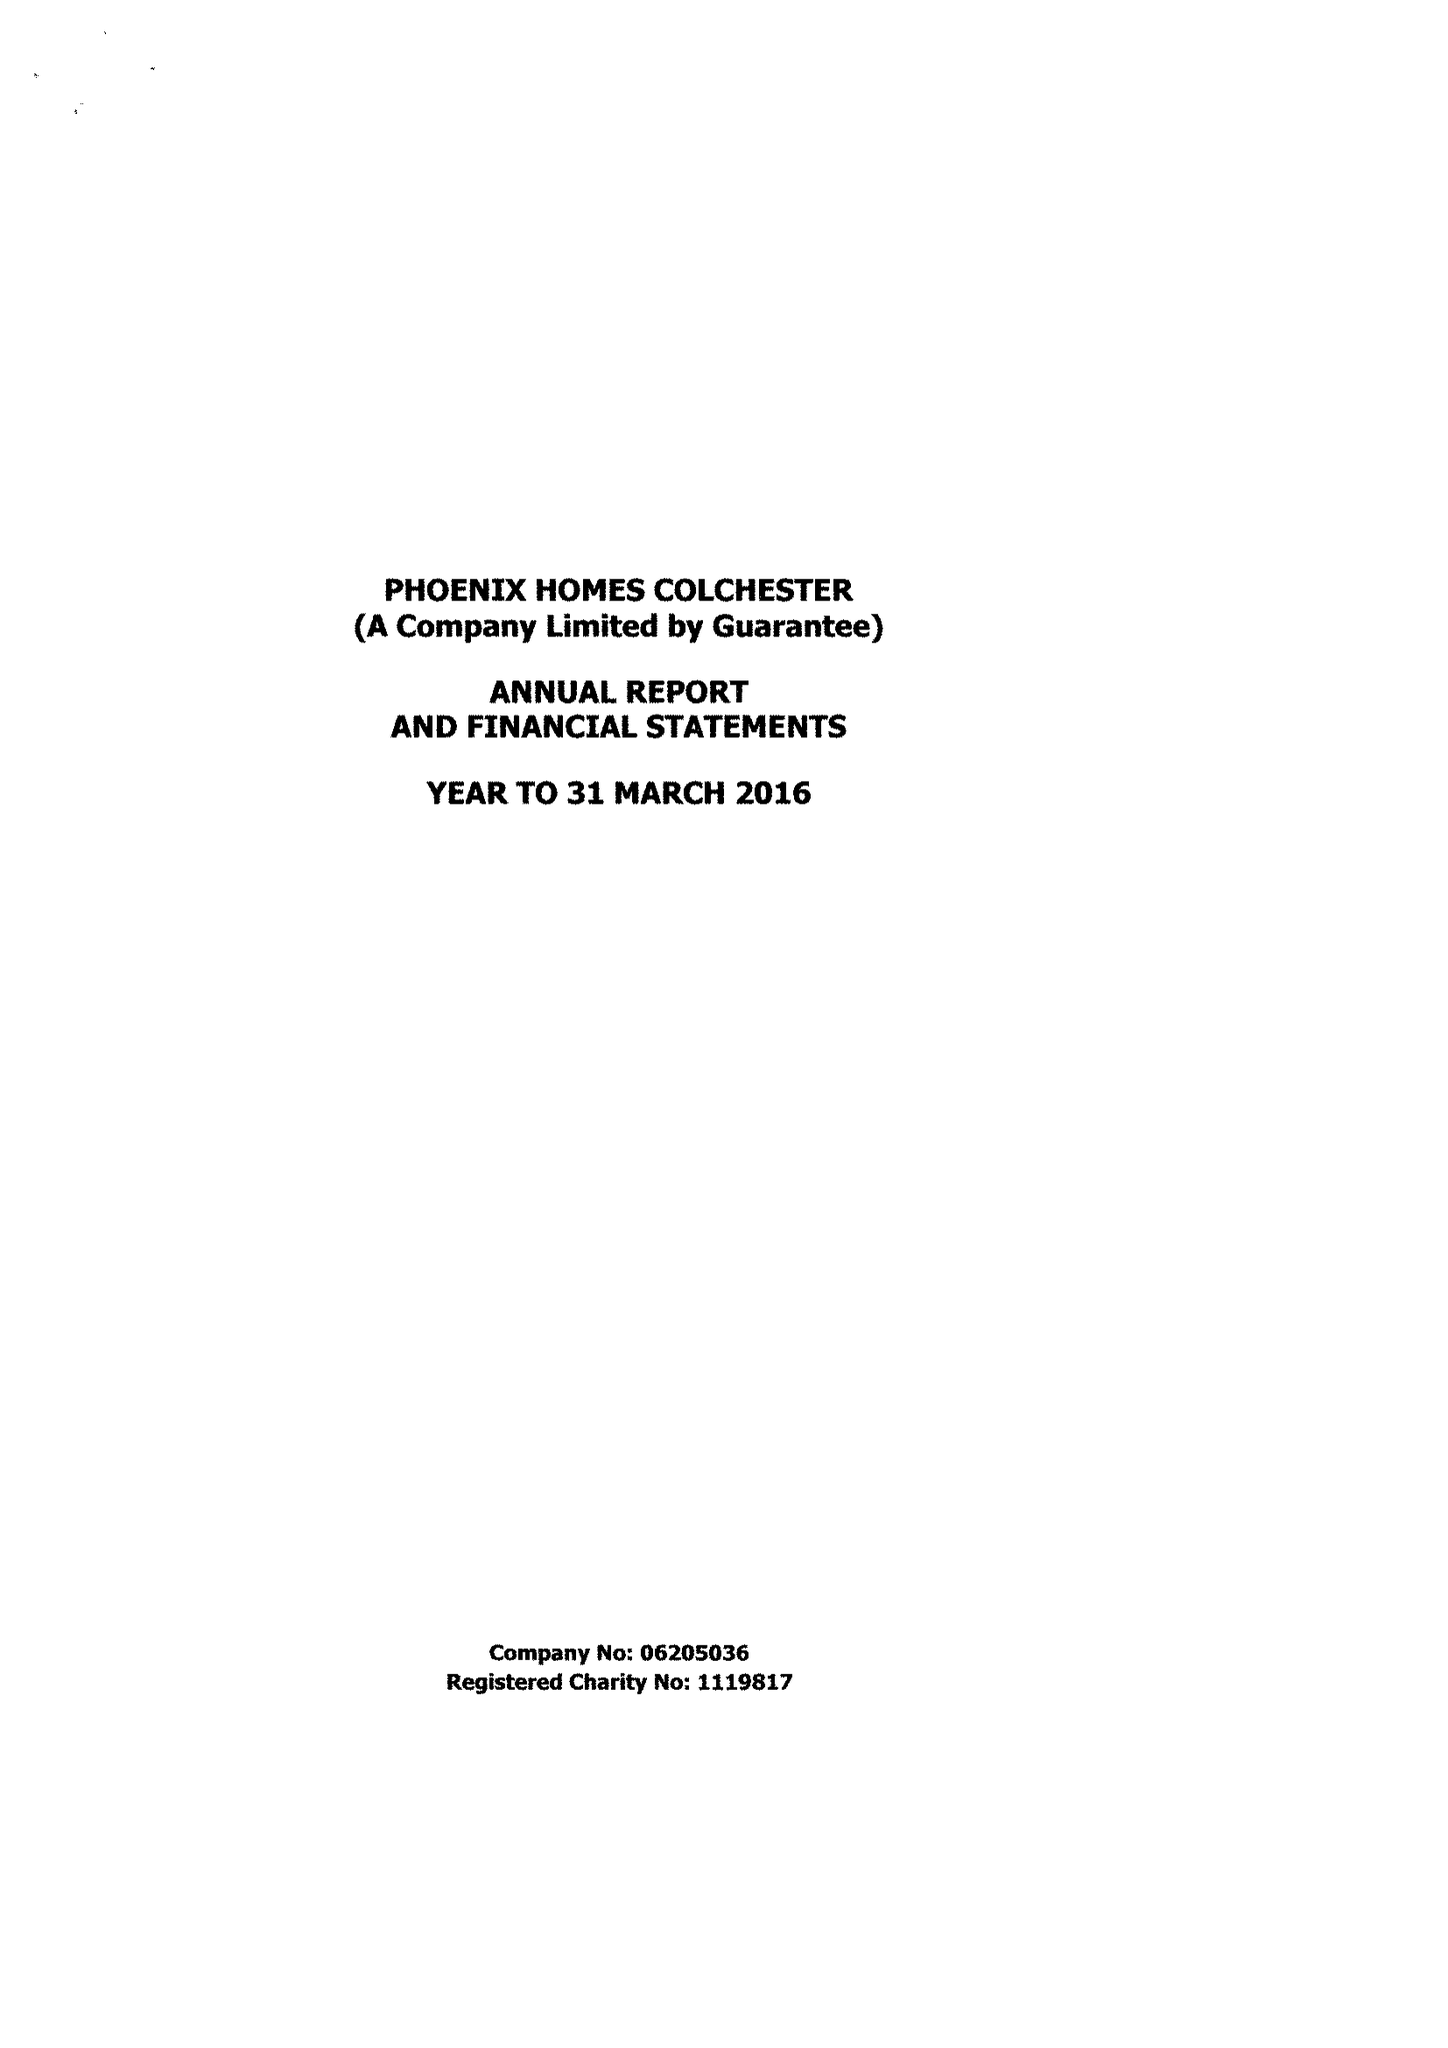What is the value for the charity_number?
Answer the question using a single word or phrase. 1119817 